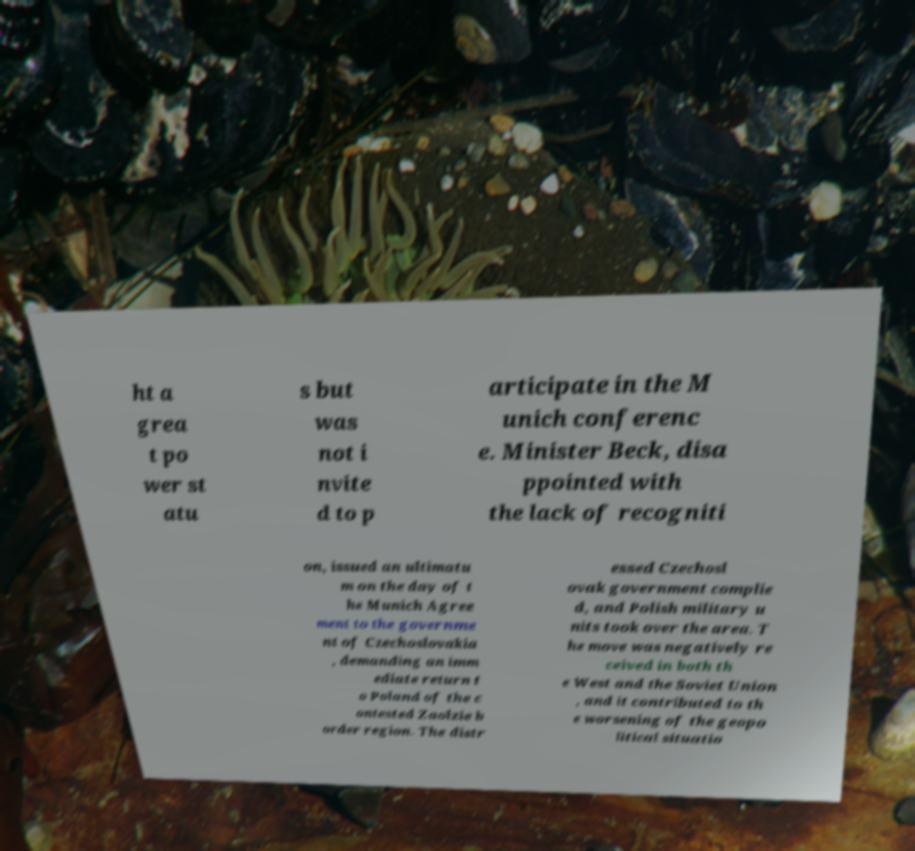Please read and relay the text visible in this image. What does it say? ht a grea t po wer st atu s but was not i nvite d to p articipate in the M unich conferenc e. Minister Beck, disa ppointed with the lack of recogniti on, issued an ultimatu m on the day of t he Munich Agree ment to the governme nt of Czechoslovakia , demanding an imm ediate return t o Poland of the c ontested Zaolzie b order region. The distr essed Czechosl ovak government complie d, and Polish military u nits took over the area. T he move was negatively re ceived in both th e West and the Soviet Union , and it contributed to th e worsening of the geopo litical situatio 